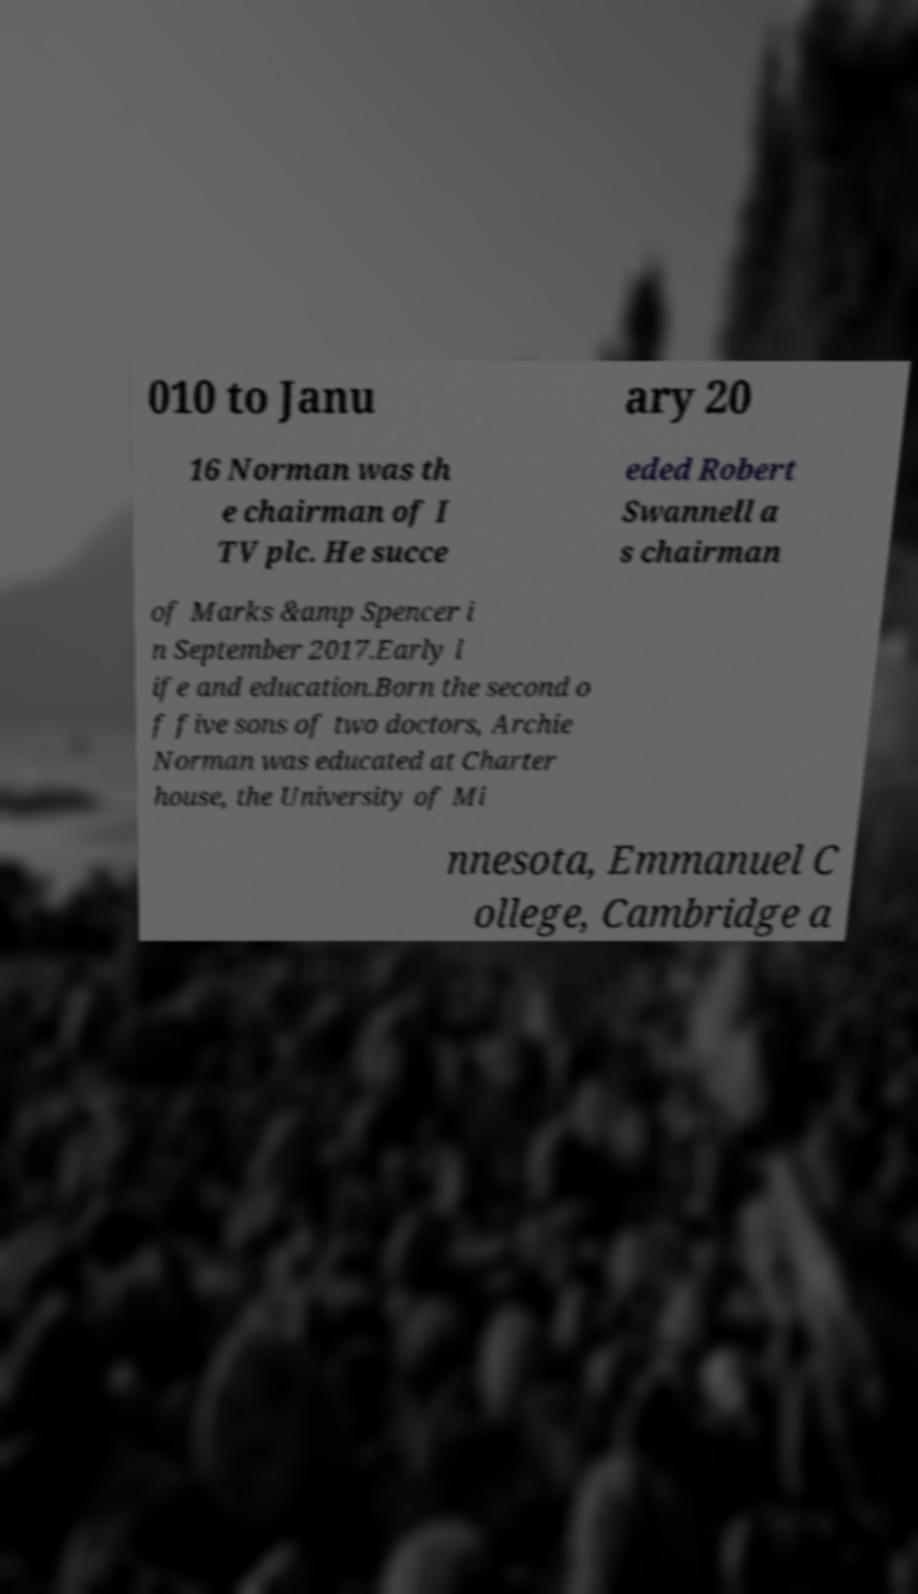Please read and relay the text visible in this image. What does it say? 010 to Janu ary 20 16 Norman was th e chairman of I TV plc. He succe eded Robert Swannell a s chairman of Marks &amp Spencer i n September 2017.Early l ife and education.Born the second o f five sons of two doctors, Archie Norman was educated at Charter house, the University of Mi nnesota, Emmanuel C ollege, Cambridge a 